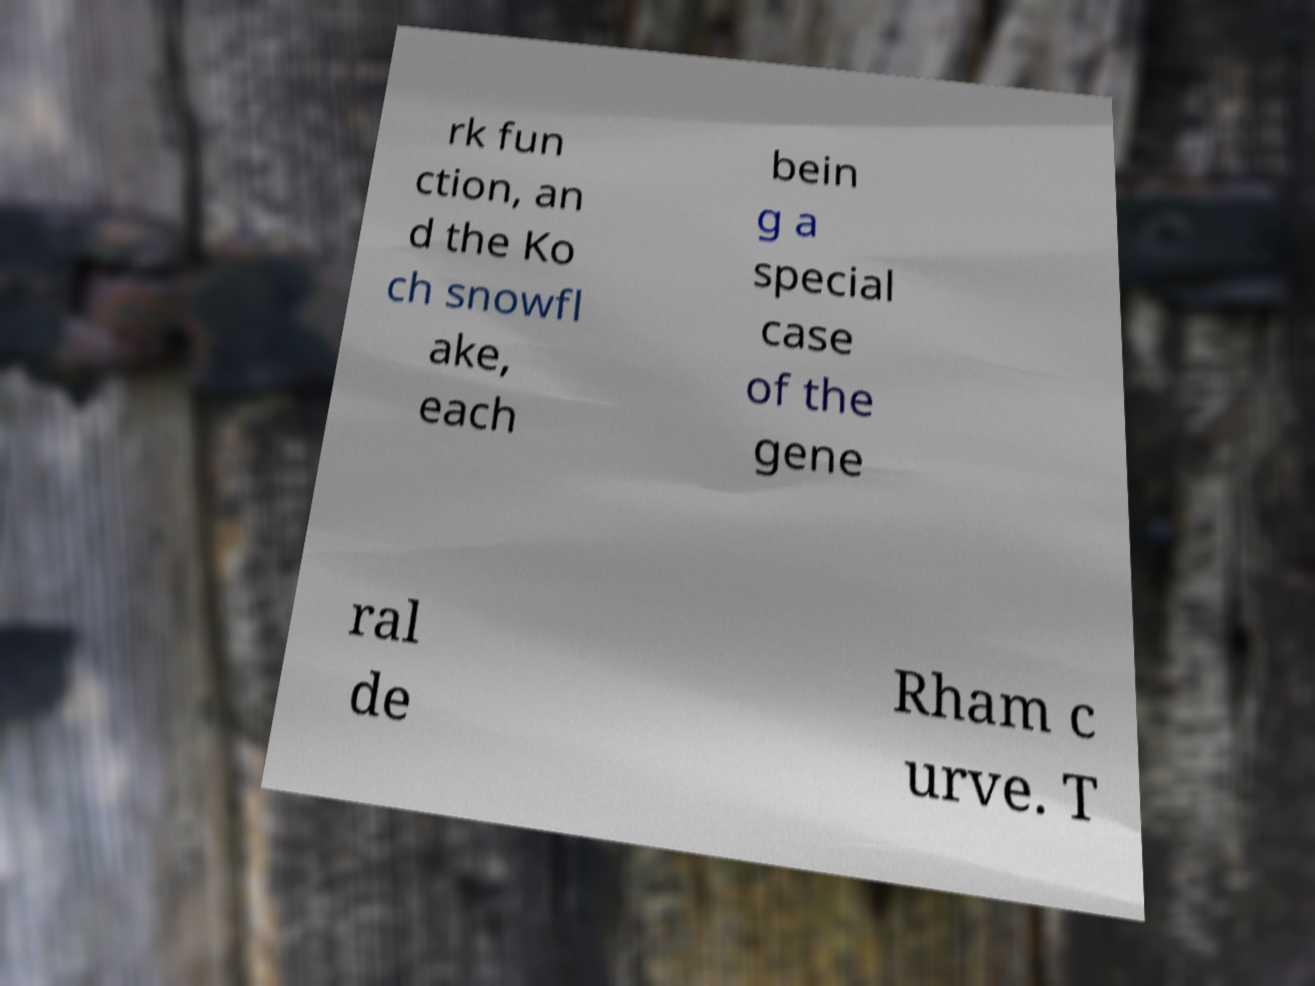Can you accurately transcribe the text from the provided image for me? rk fun ction, an d the Ko ch snowfl ake, each bein g a special case of the gene ral de Rham c urve. T 